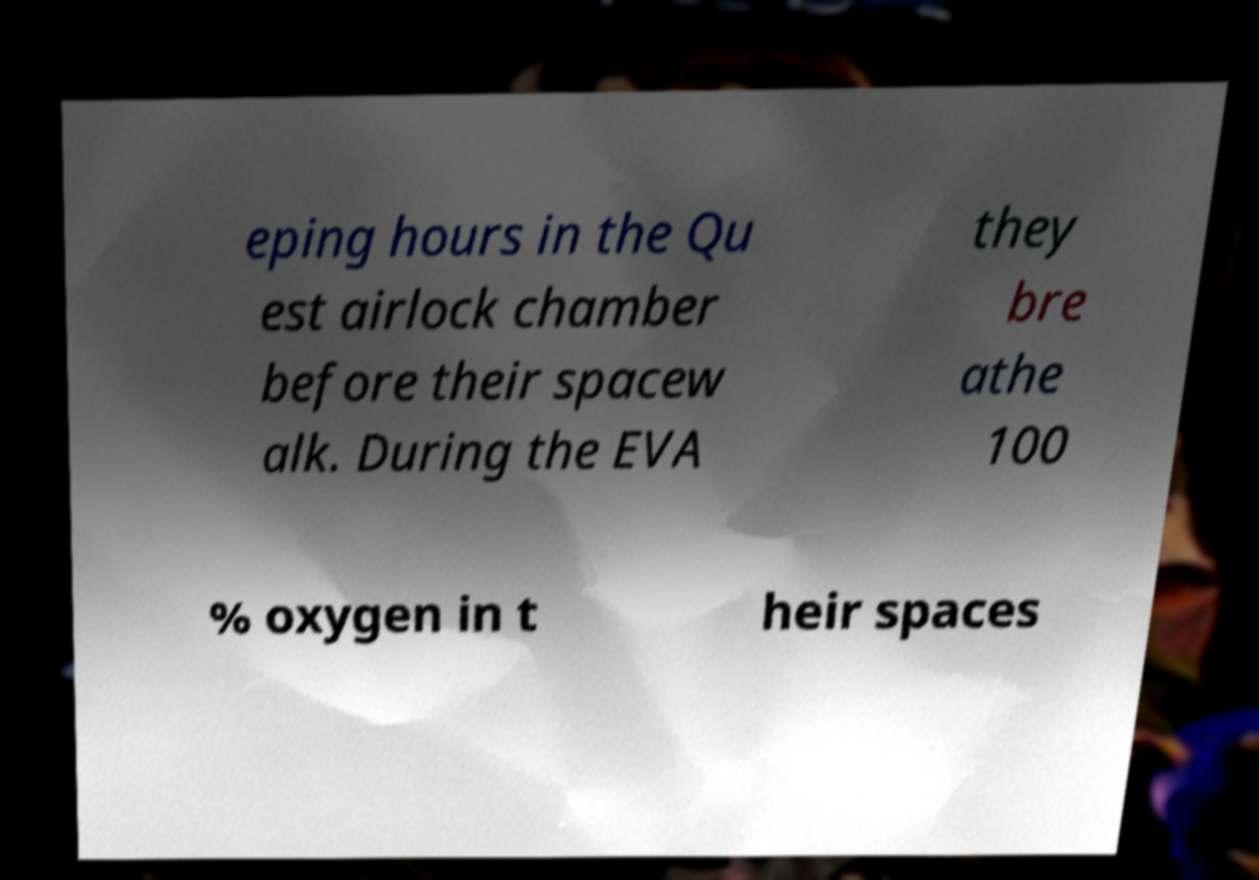I need the written content from this picture converted into text. Can you do that? eping hours in the Qu est airlock chamber before their spacew alk. During the EVA they bre athe 100 % oxygen in t heir spaces 